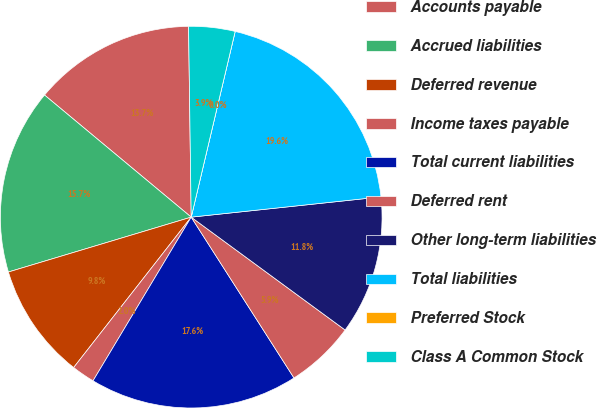Convert chart. <chart><loc_0><loc_0><loc_500><loc_500><pie_chart><fcel>Accounts payable<fcel>Accrued liabilities<fcel>Deferred revenue<fcel>Income taxes payable<fcel>Total current liabilities<fcel>Deferred rent<fcel>Other long-term liabilities<fcel>Total liabilities<fcel>Preferred Stock<fcel>Class A Common Stock<nl><fcel>13.73%<fcel>15.69%<fcel>9.8%<fcel>1.96%<fcel>17.65%<fcel>5.88%<fcel>11.76%<fcel>19.61%<fcel>0.0%<fcel>3.92%<nl></chart> 